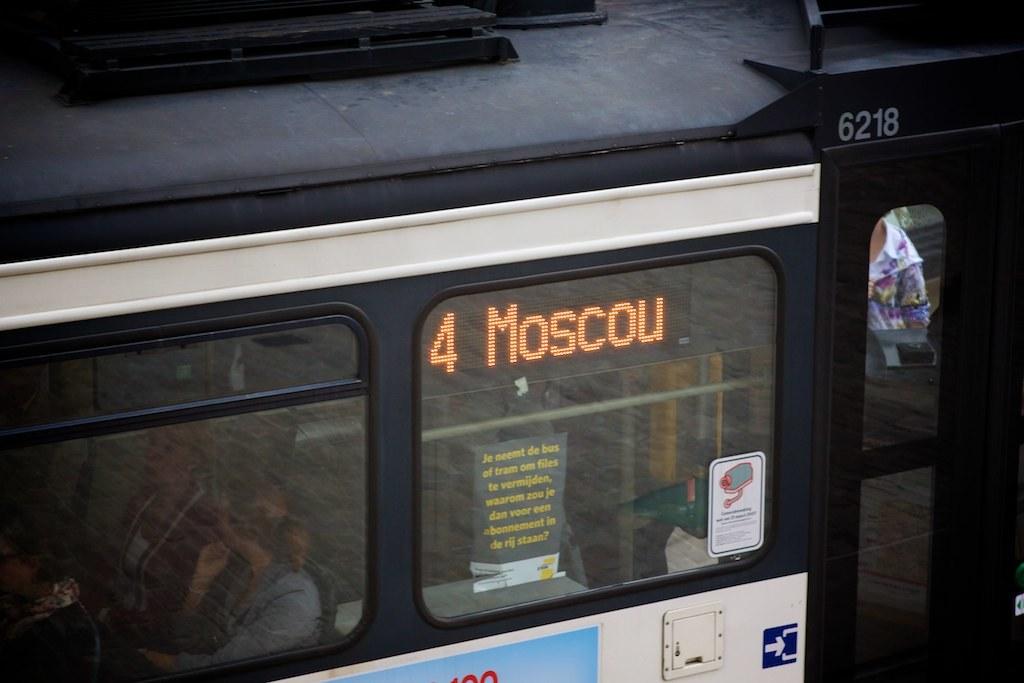What is the bus route number?
Your answer should be very brief. 4. Where is the bus going?
Provide a succinct answer. Moscou. 